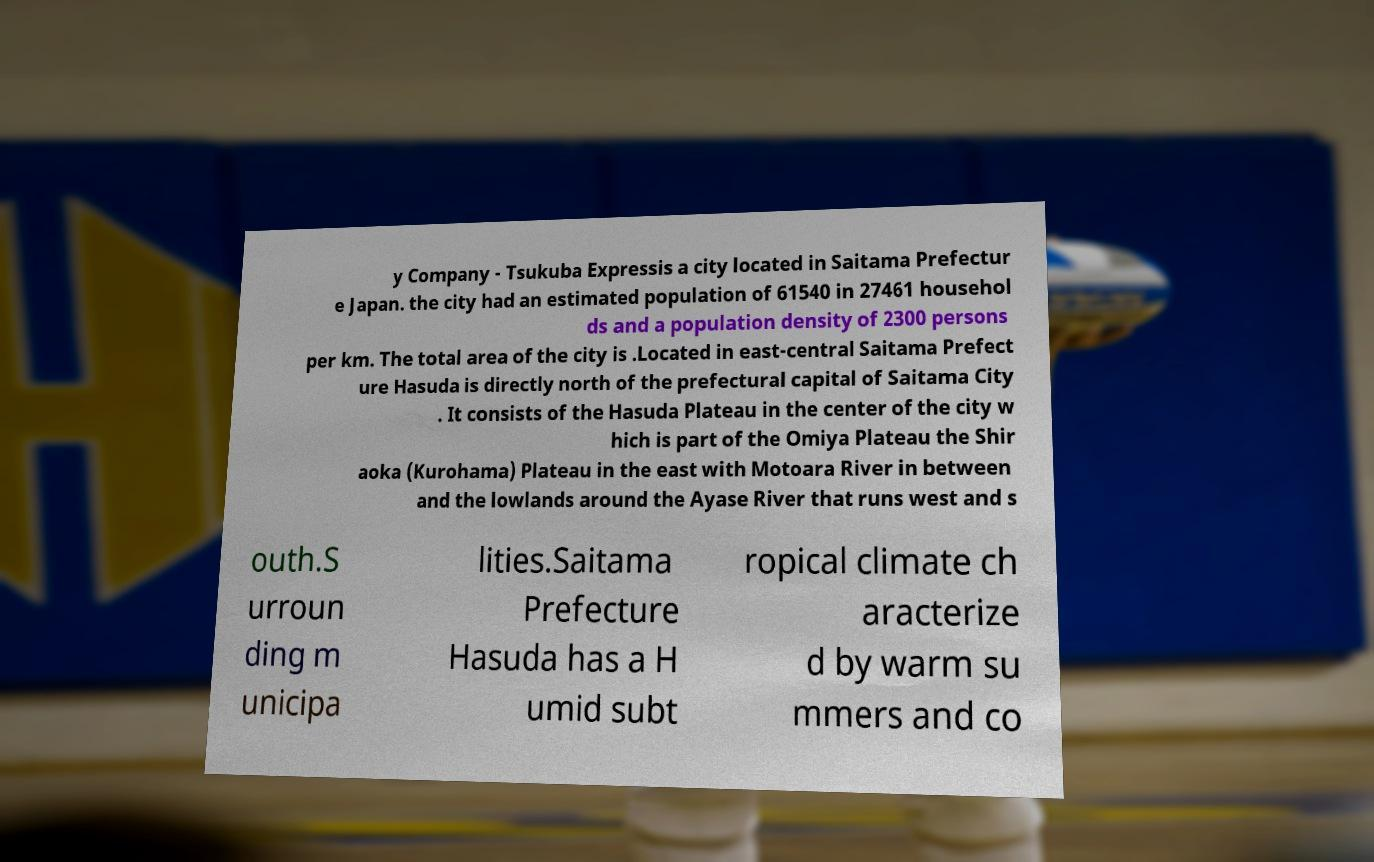Please read and relay the text visible in this image. What does it say? y Company - Tsukuba Expressis a city located in Saitama Prefectur e Japan. the city had an estimated population of 61540 in 27461 househol ds and a population density of 2300 persons per km. The total area of the city is .Located in east-central Saitama Prefect ure Hasuda is directly north of the prefectural capital of Saitama City . It consists of the Hasuda Plateau in the center of the city w hich is part of the Omiya Plateau the Shir aoka (Kurohama) Plateau in the east with Motoara River in between and the lowlands around the Ayase River that runs west and s outh.S urroun ding m unicipa lities.Saitama Prefecture Hasuda has a H umid subt ropical climate ch aracterize d by warm su mmers and co 